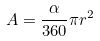<formula> <loc_0><loc_0><loc_500><loc_500>A = \frac { \alpha } { 3 6 0 } \pi r ^ { 2 }</formula> 